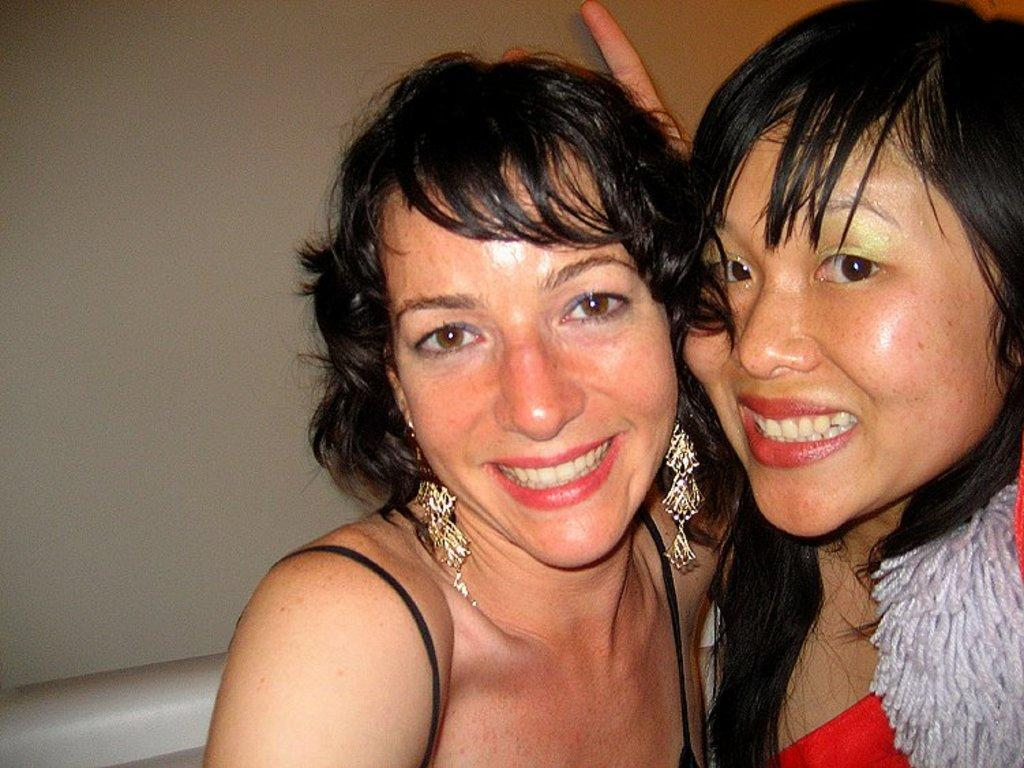How many people are present in the image? There are two persons in the image. Can you describe the object located at the left bottom of the image? Unfortunately, the provided facts do not give any information about the object at the left bottom of the image. How many girls are present at the meeting in the image? There is no information about a meeting or girls in the image, so we cannot answer this question. 